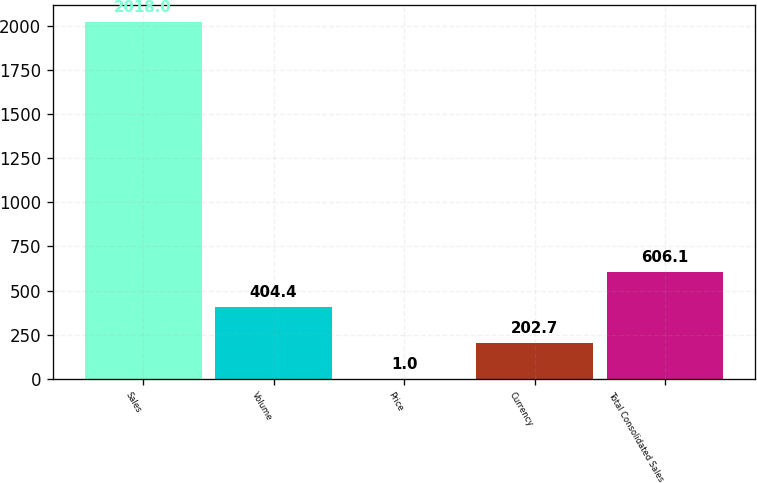Convert chart. <chart><loc_0><loc_0><loc_500><loc_500><bar_chart><fcel>Sales<fcel>Volume<fcel>Price<fcel>Currency<fcel>Total Consolidated Sales<nl><fcel>2018<fcel>404.4<fcel>1<fcel>202.7<fcel>606.1<nl></chart> 